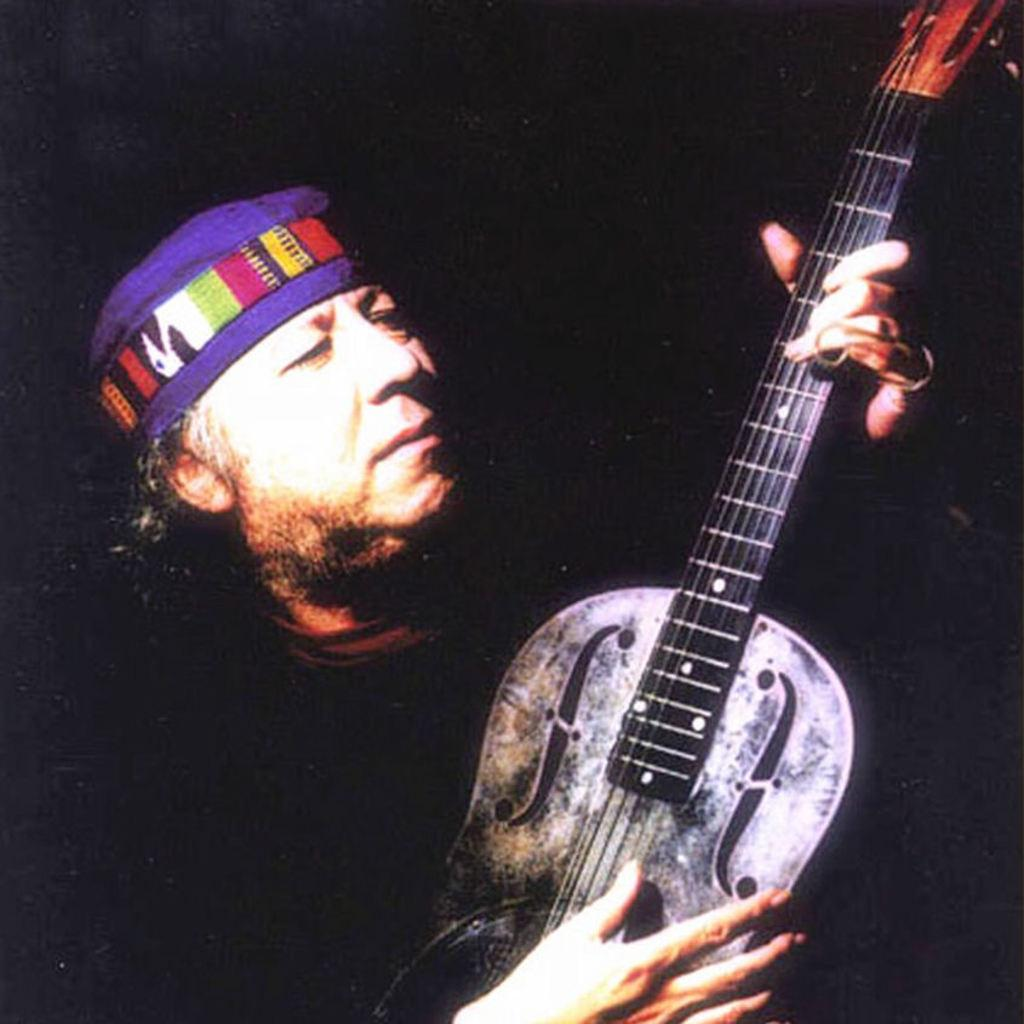What is the man in the image doing? The man is playing a guitar in the image. What is the man wearing on his head? The man is wearing a cap on his head. Reasoning: Let's think step by identifying the main subject in the image, which is the man. Then, we focus on the specific actions and accessories of the man, such as playing the guitar and wearing a cap. Each question is designed to elicit a specific detail about the image that is known from the provided facts. Absurd Question/Answer: What type of bead is the tiger wearing around its neck in the image? There is no tiger or bead present in the image; it features a man playing a guitar and wearing a cap. What type of bead is the tiger wearing around its neck in the image? There is no tiger or bead present in the image; it features a man playing a guitar and wearing a cap. 